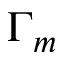<formula> <loc_0><loc_0><loc_500><loc_500>\Gamma _ { m }</formula> 